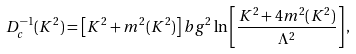<formula> <loc_0><loc_0><loc_500><loc_500>D _ { c } ^ { - 1 } ( K ^ { 2 } ) = \left [ K ^ { 2 } + m ^ { 2 } ( K ^ { 2 } ) \right ] b g ^ { 2 } \ln \left [ \frac { K ^ { 2 } + 4 m ^ { 2 } ( K ^ { 2 } ) } { \Lambda ^ { 2 } } \right ] ,</formula> 